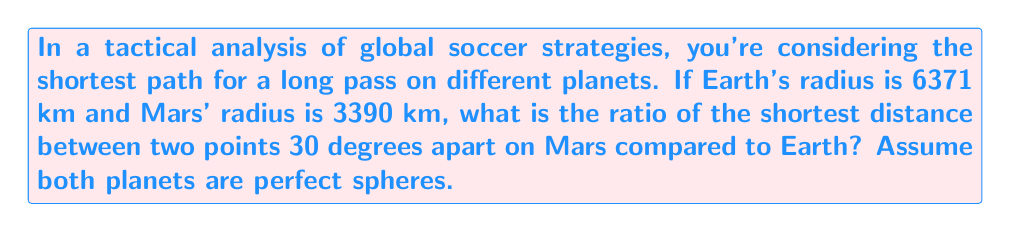Show me your answer to this math problem. Let's approach this step-by-step:

1) On a sphere, the shortest path between two points is along a great circle, called the geodesic. The length of this path is given by the arc length formula:

   $s = r\theta$

   where $s$ is the arc length, $r$ is the radius of the sphere, and $\theta$ is the central angle in radians.

2) We need to convert 30 degrees to radians:

   $\theta = 30° \times \frac{\pi}{180°} = \frac{\pi}{6}$ radians

3) For Earth:
   $s_E = 6371 \times \frac{\pi}{6} = 3333.92$ km

4) For Mars:
   $s_M = 3390 \times \frac{\pi}{6} = 1774.08$ km

5) The ratio of the distance on Mars to the distance on Earth is:

   $\frac{s_M}{s_E} = \frac{1774.08}{3333.92} = 0.5321$

6) This ratio is the same as the ratio of the radii:

   $\frac{r_M}{r_E} = \frac{3390}{6371} = 0.5321$

This makes sense because the arc length is directly proportional to the radius when the angle is the same.
Answer: 0.5321 